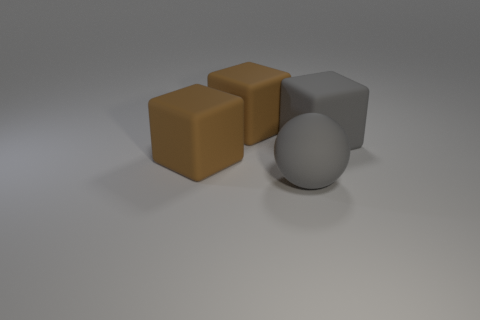Subtract all big brown rubber cubes. How many cubes are left? 1 Subtract all yellow cylinders. How many brown cubes are left? 2 Add 4 big balls. How many objects exist? 8 Subtract all gray blocks. How many blocks are left? 2 Add 1 gray rubber blocks. How many gray rubber blocks exist? 2 Subtract 0 gray cylinders. How many objects are left? 4 Subtract all spheres. How many objects are left? 3 Subtract 1 spheres. How many spheres are left? 0 Subtract all blue spheres. Subtract all brown cylinders. How many spheres are left? 1 Subtract all gray things. Subtract all small brown metal spheres. How many objects are left? 2 